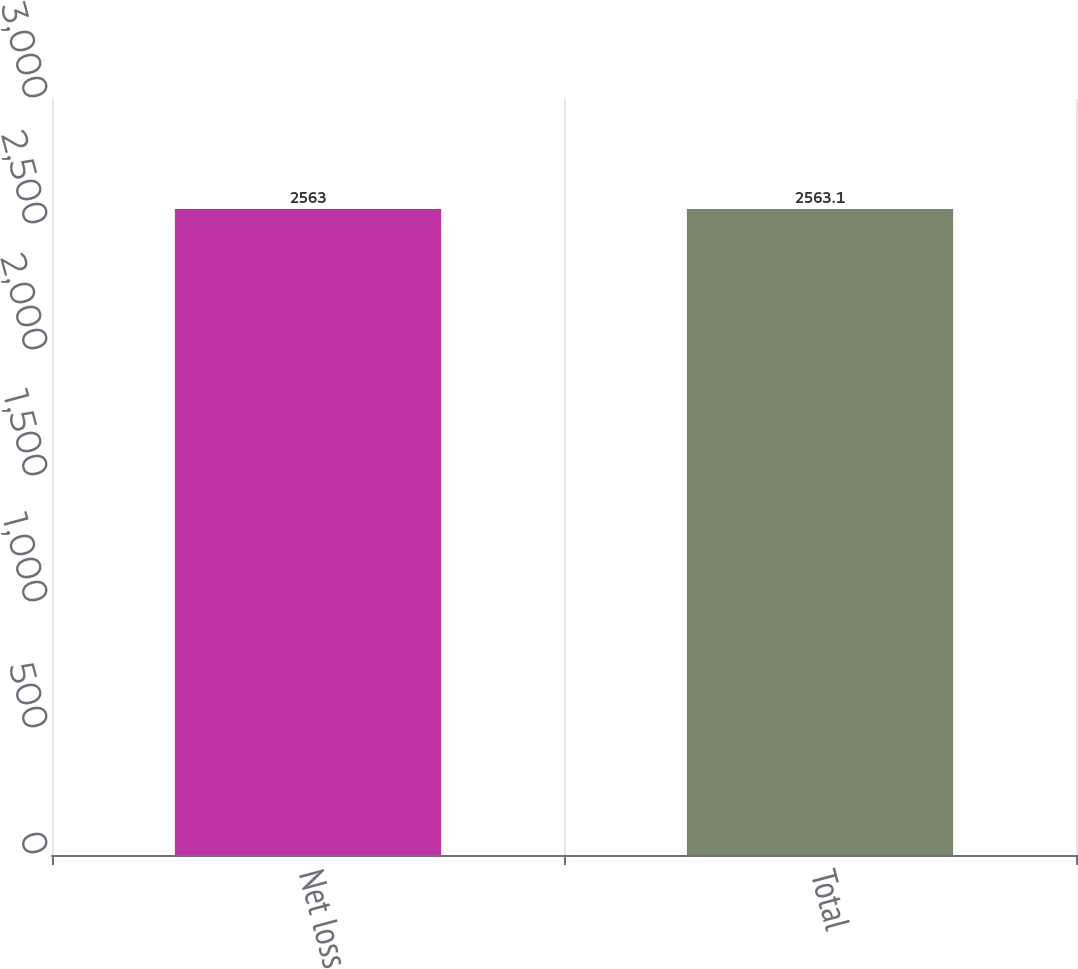Convert chart. <chart><loc_0><loc_0><loc_500><loc_500><bar_chart><fcel>Net loss<fcel>Total<nl><fcel>2563<fcel>2563.1<nl></chart> 